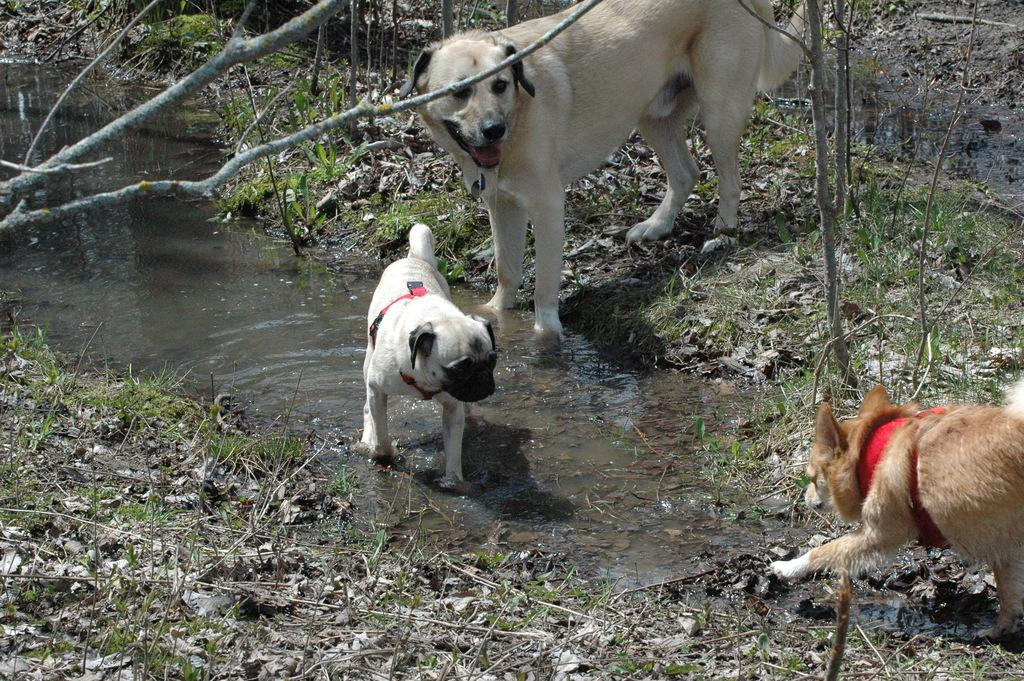What type of animals are in the image? There are dogs in the image. What is the primary element visible in the image? Water is visible in the image. What can be seen in the background of the image? There are trees in the background of the image. What type of terrain is at the bottom of the image? There is grass at the bottom of the image. What type of yam is being used as a toy by the dogs in the image? There is no yam present in the image, and the dogs are not playing with any toys. 